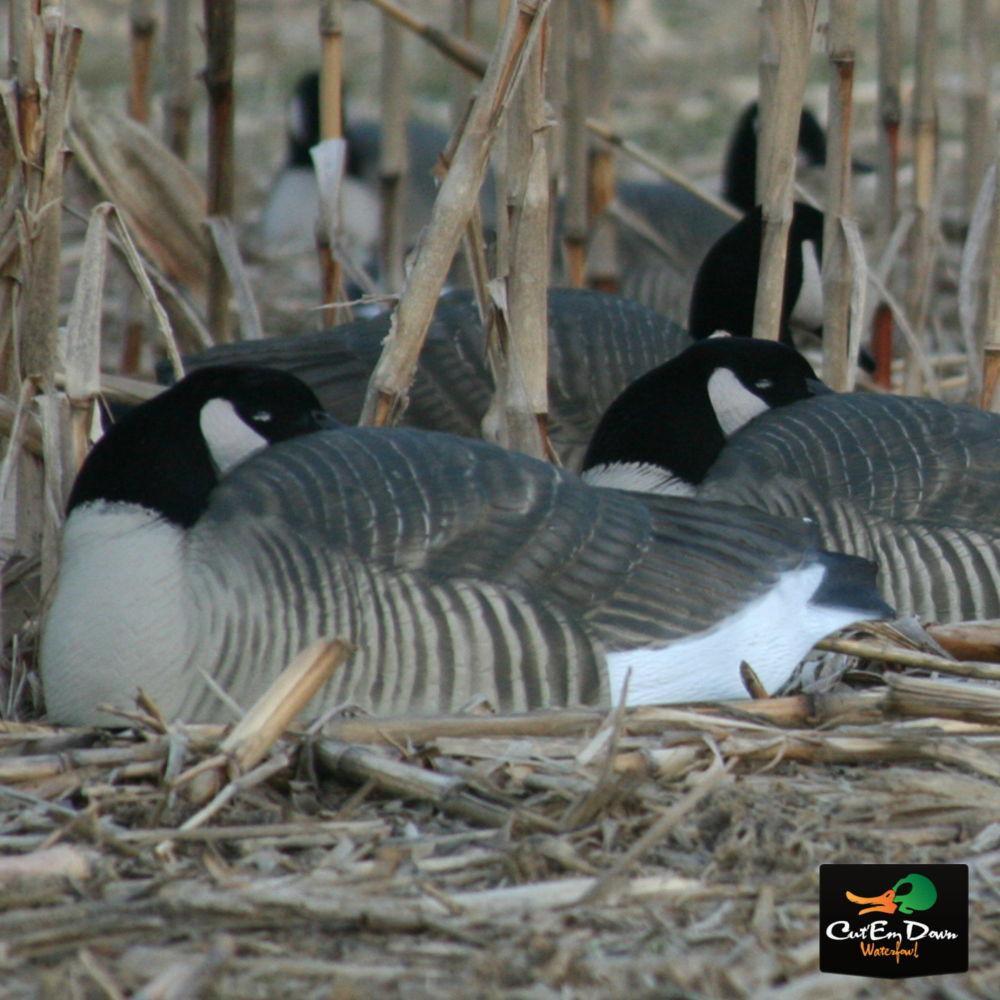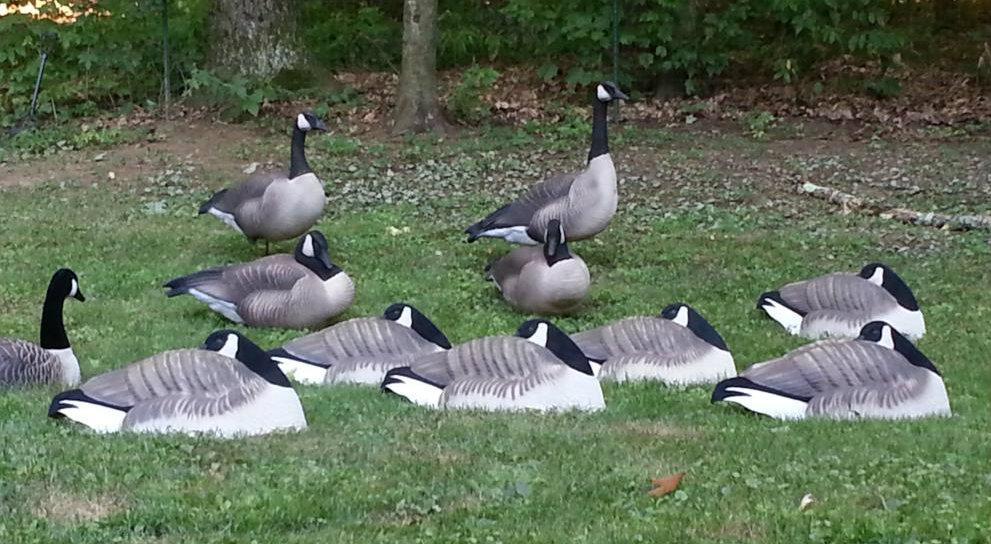The first image is the image on the left, the second image is the image on the right. Assess this claim about the two images: "The right image features a duck decoy on shredded material, and no image contains more than six decoys in the foreground.". Correct or not? Answer yes or no. No. The first image is the image on the left, the second image is the image on the right. Examine the images to the left and right. Is the description "The birds in at least one of the images are near a tree surrounded area." accurate? Answer yes or no. Yes. 